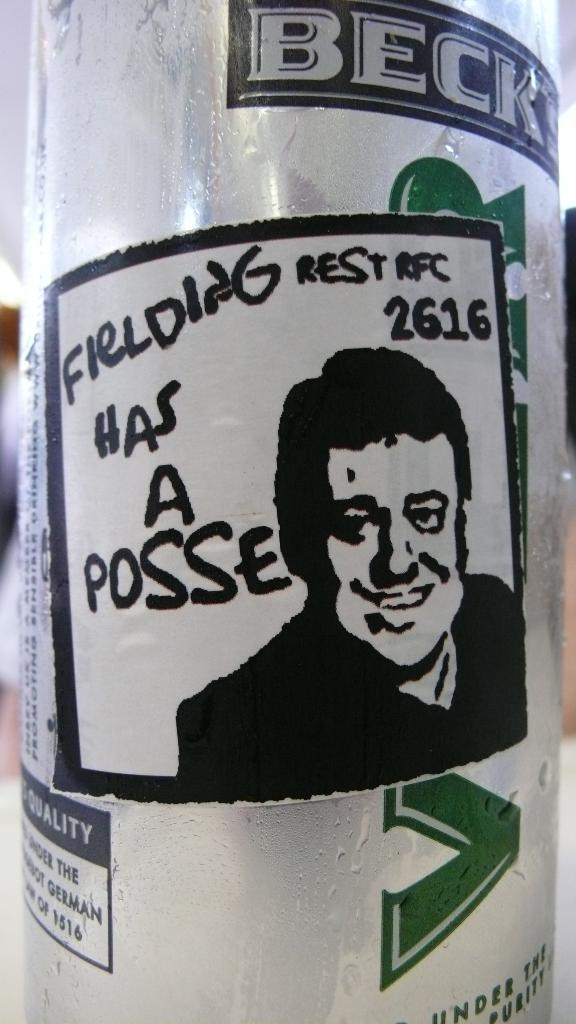What object can be seen in the picture? There is a bottle in the picture. What is depicted on the bottle? There is a picture of a man on the bottle. What type of church can be seen in the background of the picture? There is no church present in the image; it only features a bottle with a picture of a man. 